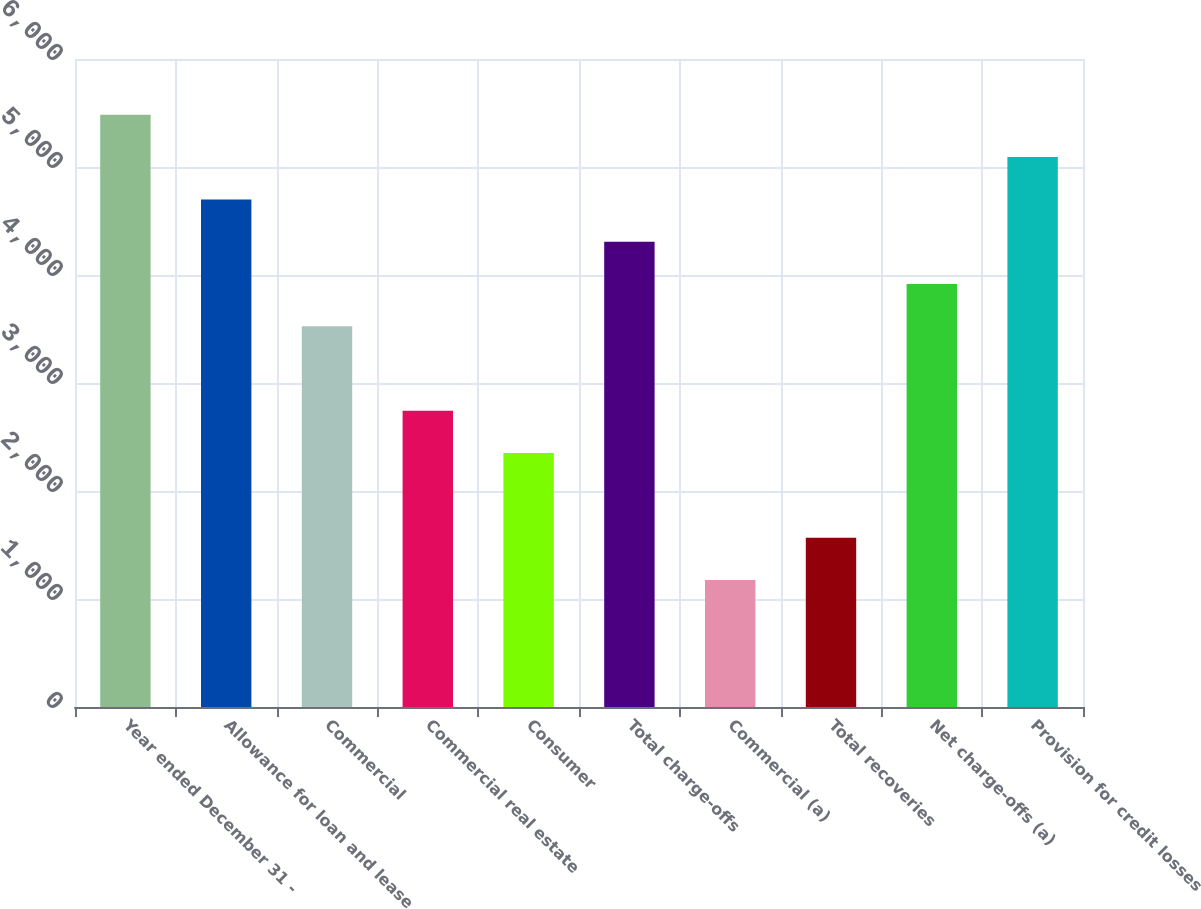<chart> <loc_0><loc_0><loc_500><loc_500><bar_chart><fcel>Year ended December 31 -<fcel>Allowance for loan and lease<fcel>Commercial<fcel>Commercial real estate<fcel>Consumer<fcel>Total charge-offs<fcel>Commercial (a)<fcel>Total recoveries<fcel>Net charge-offs (a)<fcel>Provision for credit losses<nl><fcel>5482.95<fcel>4699.97<fcel>3525.5<fcel>2742.52<fcel>2351.03<fcel>4308.48<fcel>1176.56<fcel>1568.05<fcel>3916.99<fcel>5091.46<nl></chart> 